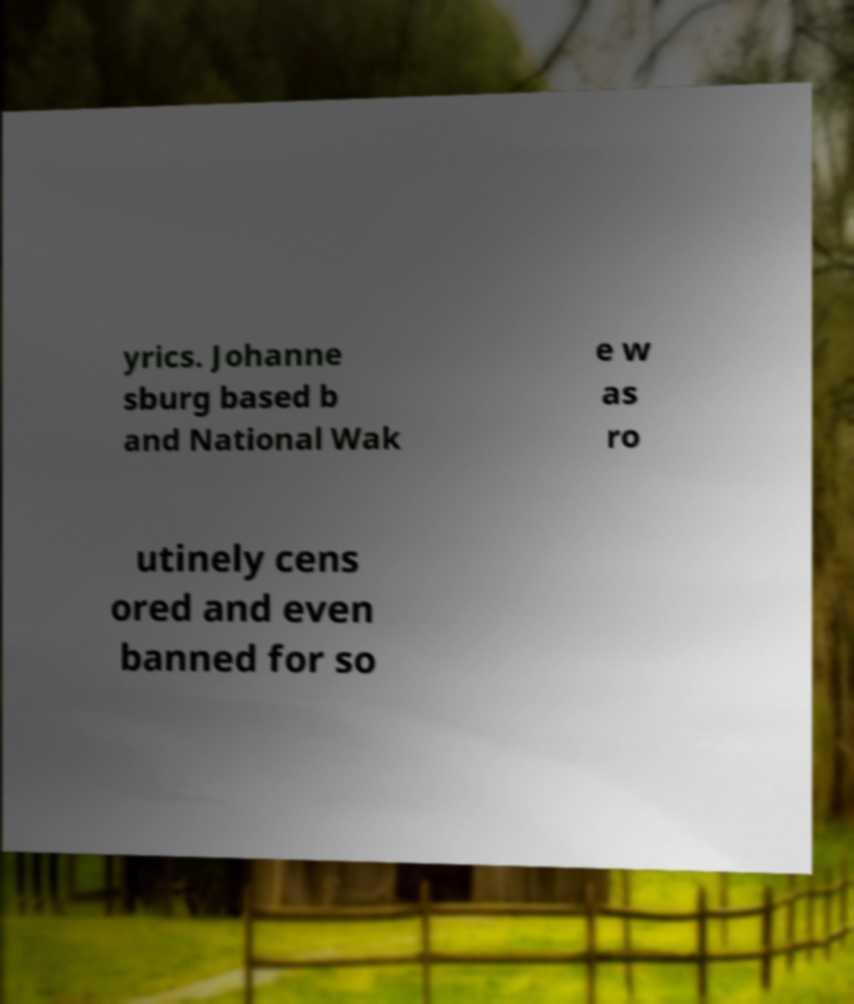Please read and relay the text visible in this image. What does it say? yrics. Johanne sburg based b and National Wak e w as ro utinely cens ored and even banned for so 